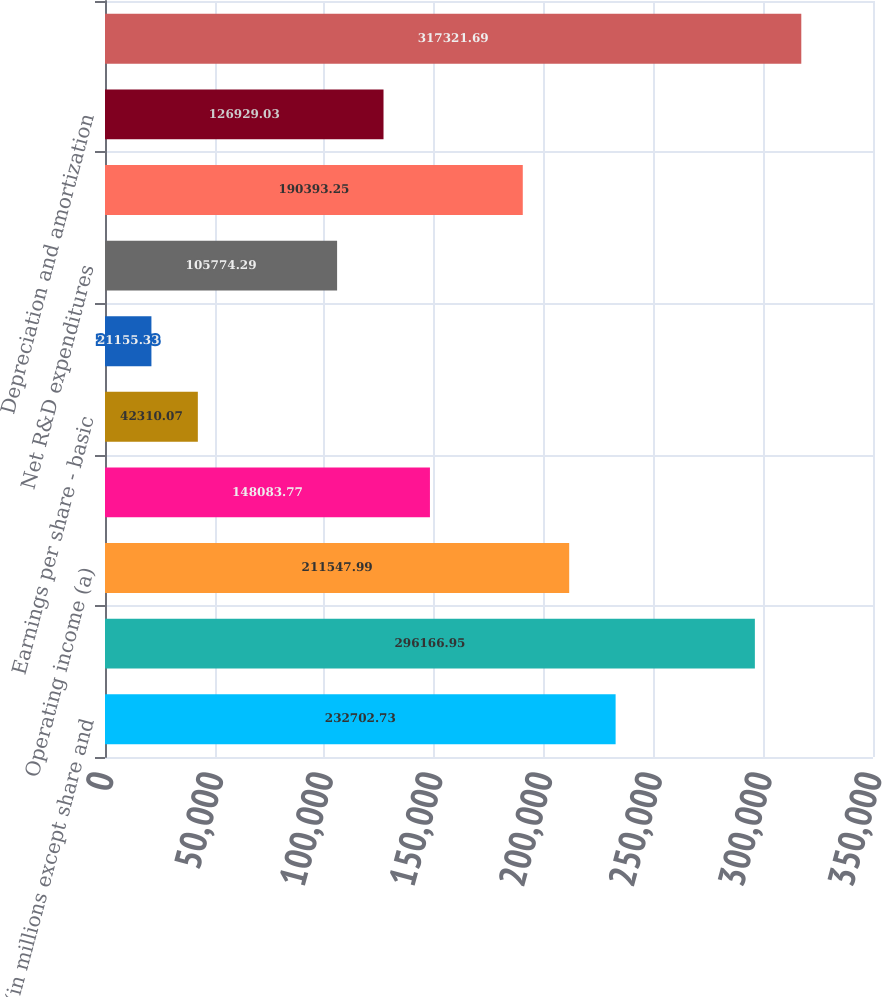Convert chart. <chart><loc_0><loc_0><loc_500><loc_500><bar_chart><fcel>(in millions except share and<fcel>Net sales<fcel>Operating income (a)<fcel>Net earnings attributable to<fcel>Earnings per share - basic<fcel>Earnings per share - diluted<fcel>Net R&D expenditures<fcel>Capital expenditures including<fcel>Depreciation and amortization<fcel>Number of employees<nl><fcel>232703<fcel>296167<fcel>211548<fcel>148084<fcel>42310.1<fcel>21155.3<fcel>105774<fcel>190393<fcel>126929<fcel>317322<nl></chart> 